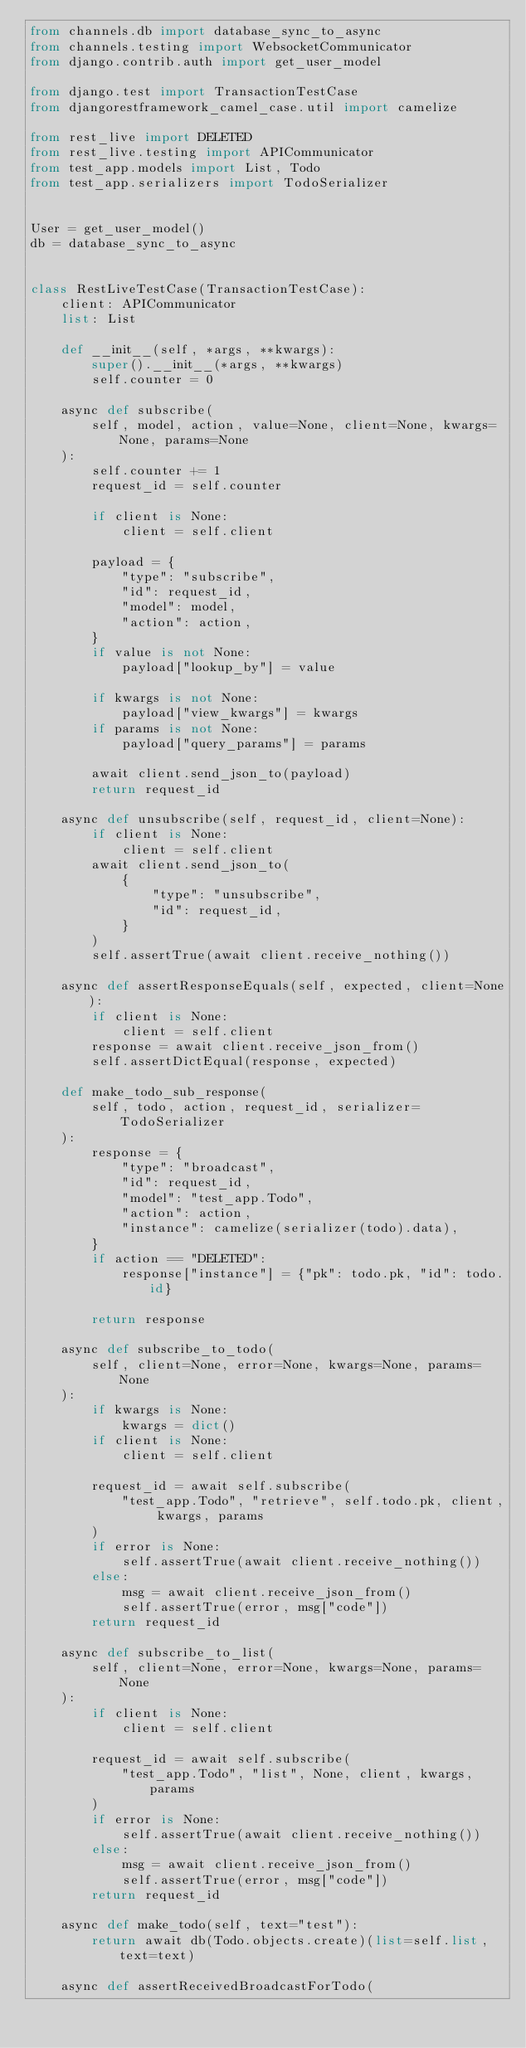Convert code to text. <code><loc_0><loc_0><loc_500><loc_500><_Python_>from channels.db import database_sync_to_async
from channels.testing import WebsocketCommunicator
from django.contrib.auth import get_user_model

from django.test import TransactionTestCase
from djangorestframework_camel_case.util import camelize

from rest_live import DELETED
from rest_live.testing import APICommunicator
from test_app.models import List, Todo
from test_app.serializers import TodoSerializer


User = get_user_model()
db = database_sync_to_async


class RestLiveTestCase(TransactionTestCase):
    client: APICommunicator
    list: List

    def __init__(self, *args, **kwargs):
        super().__init__(*args, **kwargs)
        self.counter = 0

    async def subscribe(
        self, model, action, value=None, client=None, kwargs=None, params=None
    ):
        self.counter += 1
        request_id = self.counter

        if client is None:
            client = self.client

        payload = {
            "type": "subscribe",
            "id": request_id,
            "model": model,
            "action": action,
        }
        if value is not None:
            payload["lookup_by"] = value

        if kwargs is not None:
            payload["view_kwargs"] = kwargs
        if params is not None:
            payload["query_params"] = params

        await client.send_json_to(payload)
        return request_id

    async def unsubscribe(self, request_id, client=None):
        if client is None:
            client = self.client
        await client.send_json_to(
            {
                "type": "unsubscribe",
                "id": request_id,
            }
        )
        self.assertTrue(await client.receive_nothing())

    async def assertResponseEquals(self, expected, client=None):
        if client is None:
            client = self.client
        response = await client.receive_json_from()
        self.assertDictEqual(response, expected)

    def make_todo_sub_response(
        self, todo, action, request_id, serializer=TodoSerializer
    ):
        response = {
            "type": "broadcast",
            "id": request_id,
            "model": "test_app.Todo",
            "action": action,
            "instance": camelize(serializer(todo).data),
        }
        if action == "DELETED":
            response["instance"] = {"pk": todo.pk, "id": todo.id}

        return response

    async def subscribe_to_todo(
        self, client=None, error=None, kwargs=None, params=None
    ):
        if kwargs is None:
            kwargs = dict()
        if client is None:
            client = self.client

        request_id = await self.subscribe(
            "test_app.Todo", "retrieve", self.todo.pk, client, kwargs, params
        )
        if error is None:
            self.assertTrue(await client.receive_nothing())
        else:
            msg = await client.receive_json_from()
            self.assertTrue(error, msg["code"])
        return request_id

    async def subscribe_to_list(
        self, client=None, error=None, kwargs=None, params=None
    ):
        if client is None:
            client = self.client

        request_id = await self.subscribe(
            "test_app.Todo", "list", None, client, kwargs, params
        )
        if error is None:
            self.assertTrue(await client.receive_nothing())
        else:
            msg = await client.receive_json_from()
            self.assertTrue(error, msg["code"])
        return request_id

    async def make_todo(self, text="test"):
        return await db(Todo.objects.create)(list=self.list, text=text)

    async def assertReceivedBroadcastForTodo(</code> 